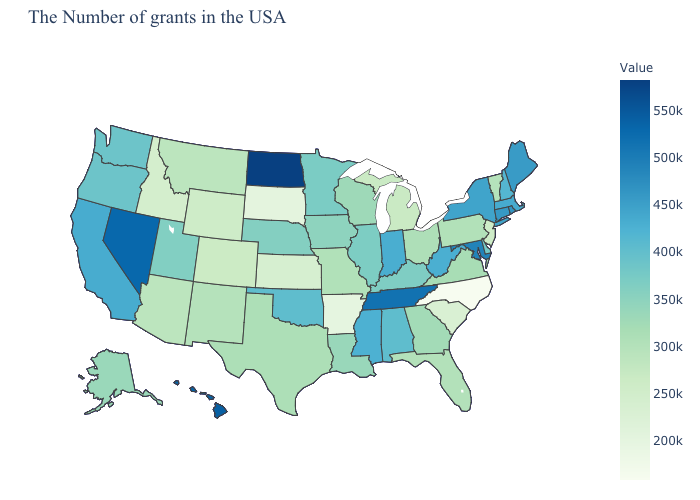Does Mississippi have a higher value than Missouri?
Write a very short answer. Yes. Which states have the highest value in the USA?
Short answer required. North Dakota. Does North Dakota have the highest value in the USA?
Answer briefly. Yes. Does Tennessee have the highest value in the South?
Quick response, please. Yes. 